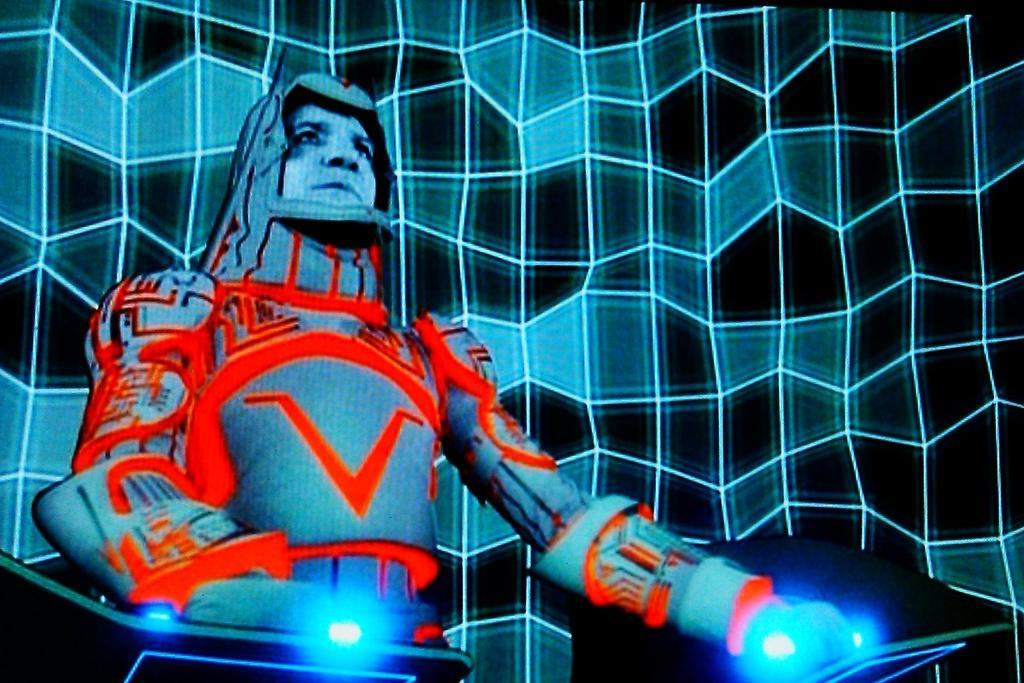Please provide a concise description of this image. In the image we can see an animated image picture of a person standing, wearing costume. These are lights and the background is pale blue and dark in color. 